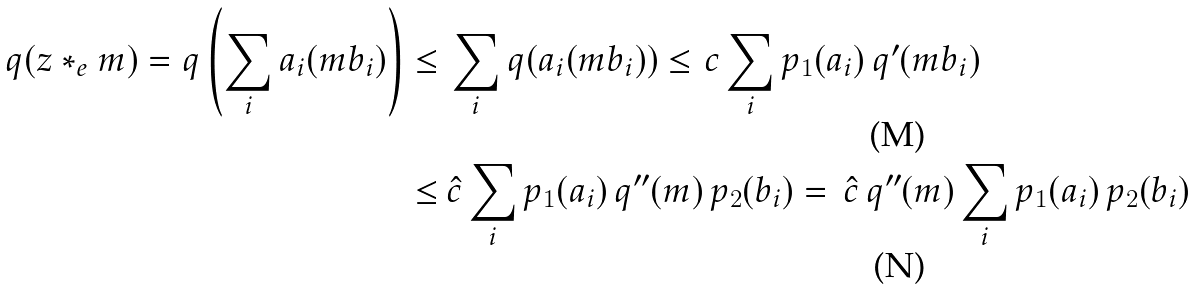Convert formula to latex. <formula><loc_0><loc_0><loc_500><loc_500>q ( z * _ { e } m ) = q \left ( \sum _ { i } a _ { i } ( m b _ { i } ) \right ) \leq & \, \sum _ { i } q ( a _ { i } ( m b _ { i } ) ) \leq c \sum _ { i } p _ { 1 } ( a _ { i } ) \, q ^ { \prime } ( m b _ { i } ) \\ \leq & \, \hat { c } \sum _ { i } p _ { 1 } ( a _ { i } ) \, q ^ { \prime \prime } ( m ) \, p _ { 2 } ( b _ { i } ) = \, \hat { c } \, q ^ { \prime \prime } ( m ) \sum _ { i } p _ { 1 } ( a _ { i } ) \, p _ { 2 } ( b _ { i } )</formula> 